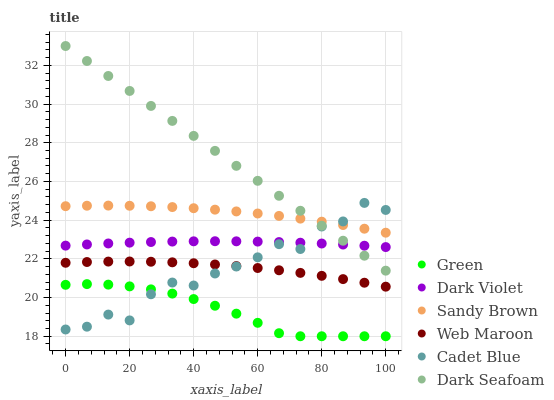Does Green have the minimum area under the curve?
Answer yes or no. Yes. Does Dark Seafoam have the maximum area under the curve?
Answer yes or no. Yes. Does Web Maroon have the minimum area under the curve?
Answer yes or no. No. Does Web Maroon have the maximum area under the curve?
Answer yes or no. No. Is Dark Seafoam the smoothest?
Answer yes or no. Yes. Is Cadet Blue the roughest?
Answer yes or no. Yes. Is Web Maroon the smoothest?
Answer yes or no. No. Is Web Maroon the roughest?
Answer yes or no. No. Does Green have the lowest value?
Answer yes or no. Yes. Does Web Maroon have the lowest value?
Answer yes or no. No. Does Dark Seafoam have the highest value?
Answer yes or no. Yes. Does Web Maroon have the highest value?
Answer yes or no. No. Is Green less than Dark Violet?
Answer yes or no. Yes. Is Dark Violet greater than Web Maroon?
Answer yes or no. Yes. Does Dark Seafoam intersect Cadet Blue?
Answer yes or no. Yes. Is Dark Seafoam less than Cadet Blue?
Answer yes or no. No. Is Dark Seafoam greater than Cadet Blue?
Answer yes or no. No. Does Green intersect Dark Violet?
Answer yes or no. No. 